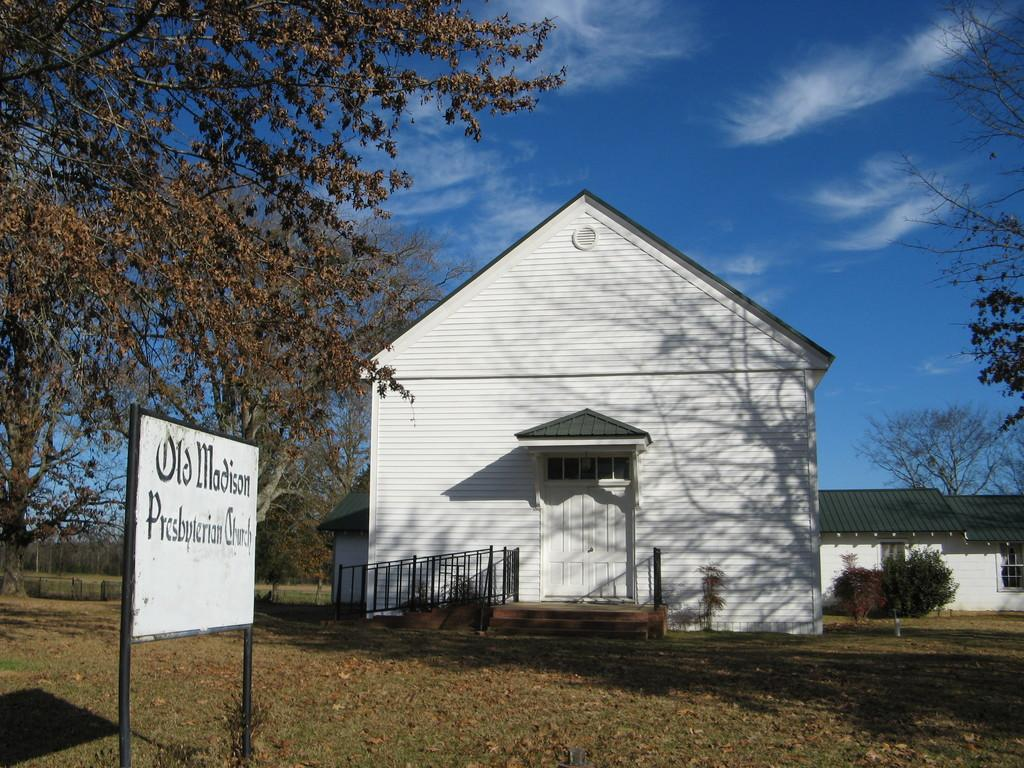What is the main structure in the image? There is a board on poles in the image. What type of natural environment is visible in the image? There is grass, trees, and plants visible in the image. What can be seen in the background of the image? There are houses, trees, plants, and the sky visible in the background of the image. What is the condition of the sky in the image? The sky is visible in the background of the image, and clouds are present. What type of pin can be seen holding the book to the ground in the image? There is no pin or book present in the image; it only features a board on poles, grass, trees, plants, houses, and the sky. 